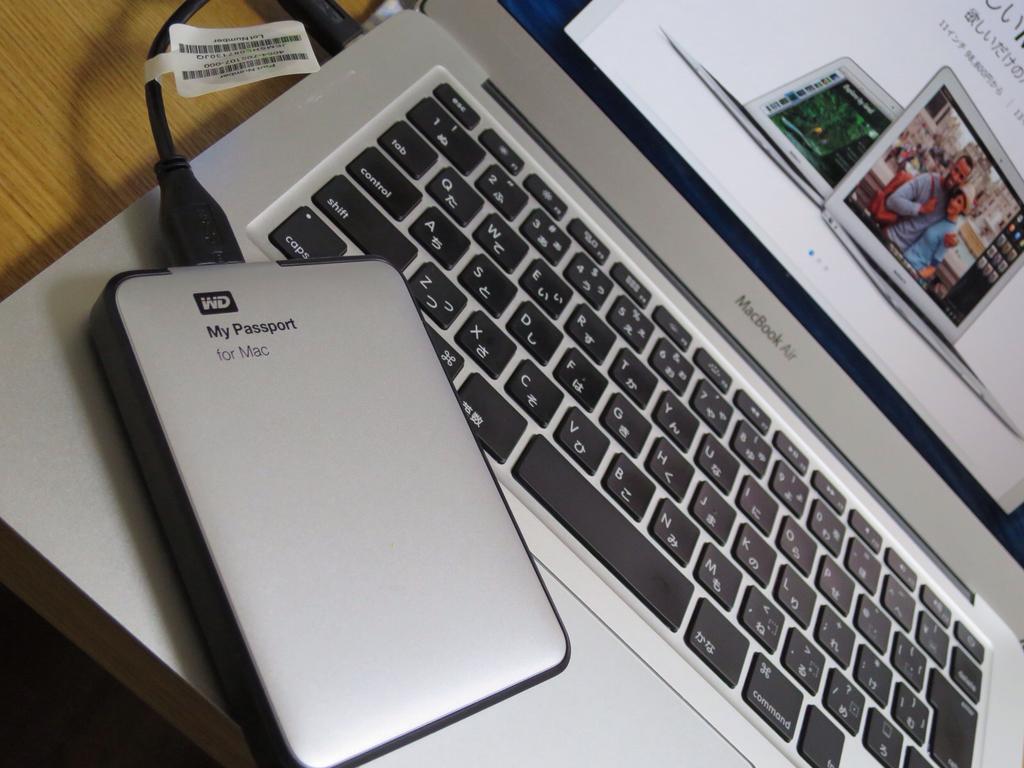Is this for mac?
Keep it short and to the point. Yes. What is the case?
Make the answer very short. My passport. 